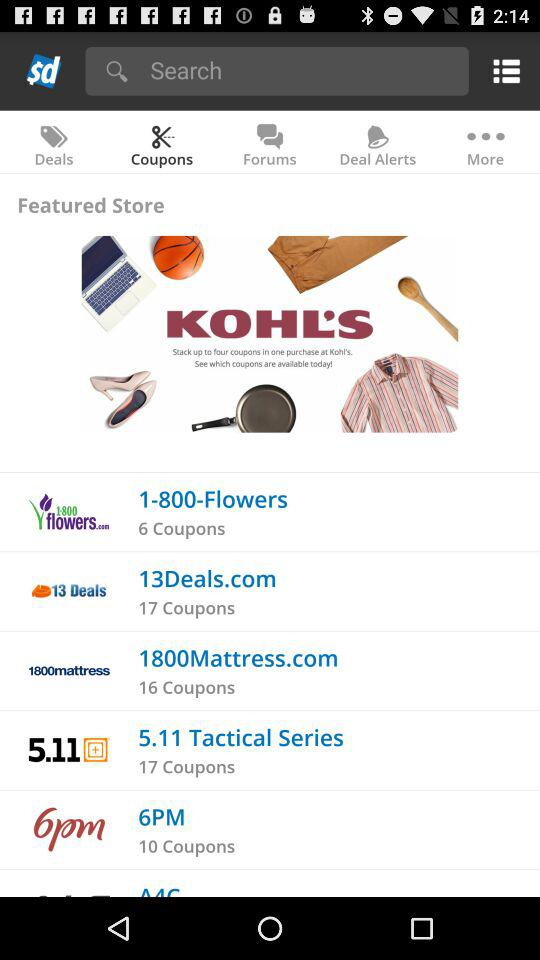How many coupons are there for "6PM"? There are 10 coupons for "6PM". 